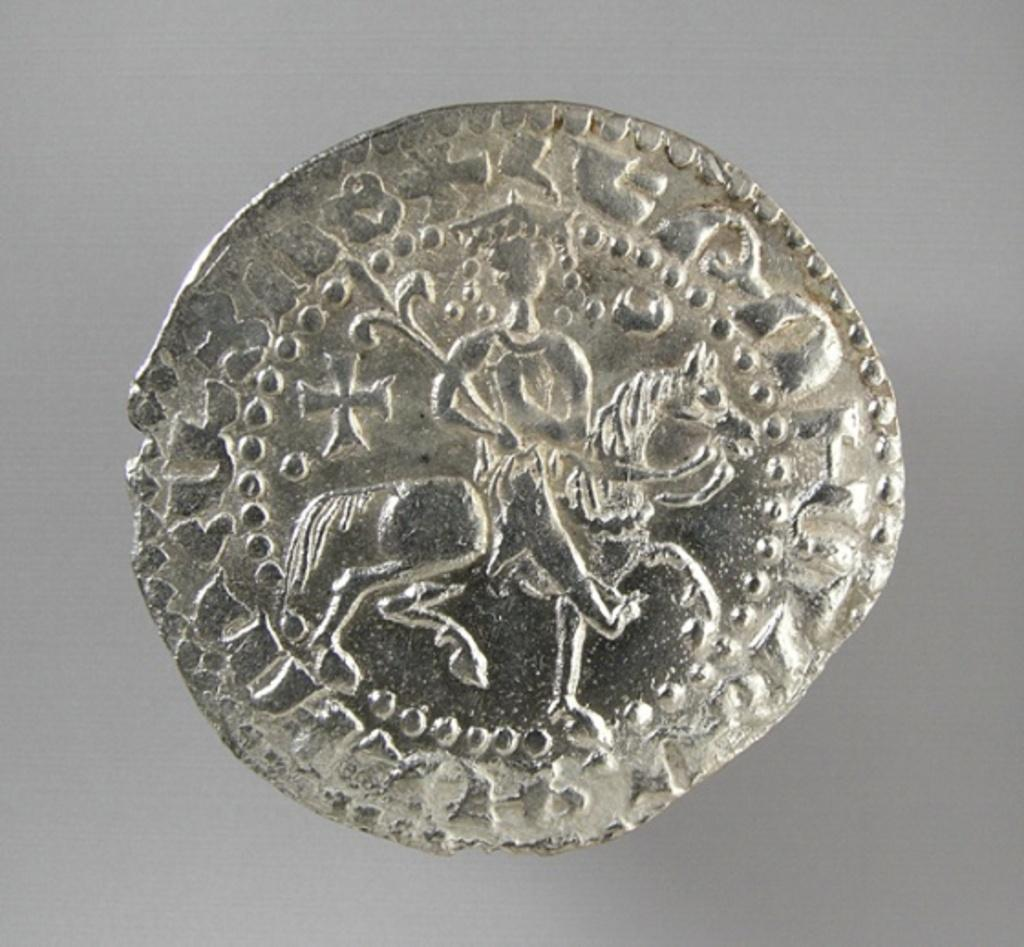What is the main subject of the image? The main subject of the image is a carved metal coin. Can you describe the surface on which the coin is placed? The coin is placed on a gray surface. What type of knife is used to carve the metal coin in the image? There is no knife present in the image, and the process of carving the metal coin is not depicted. Can you tell me where the map is located in the image? There is no map present in the image. 